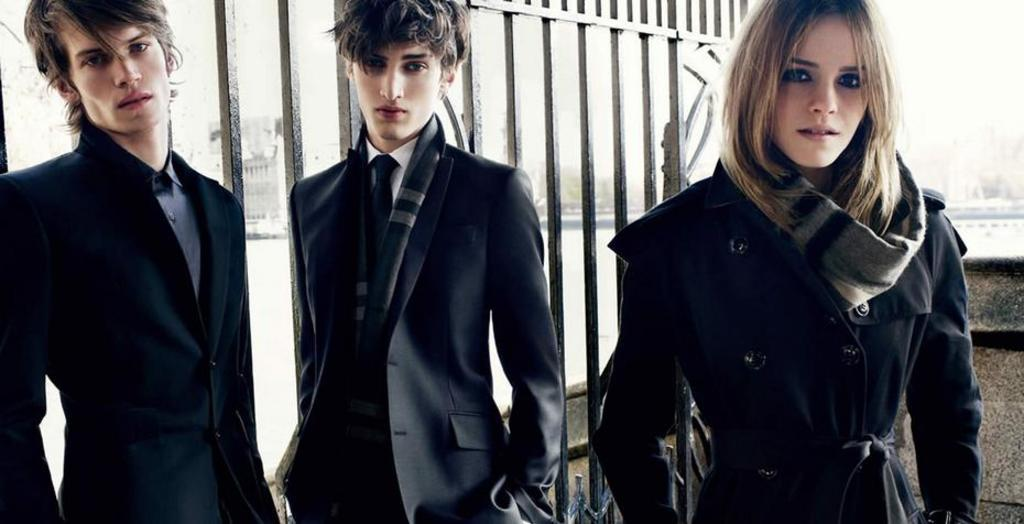How many people are in the image? There are three persons in the image. What are the people wearing? The persons are wearing black colored dresses. What are the people doing in the image? The persons are standing. What can be seen in the image besides the people? There is a metal gate and buildings visible in the image. What is the color of the background in the image? The background of the image is white. What grade did the person in the middle receive on their recent test? There is no information about a test or a grade in the image, so it cannot be determined. 